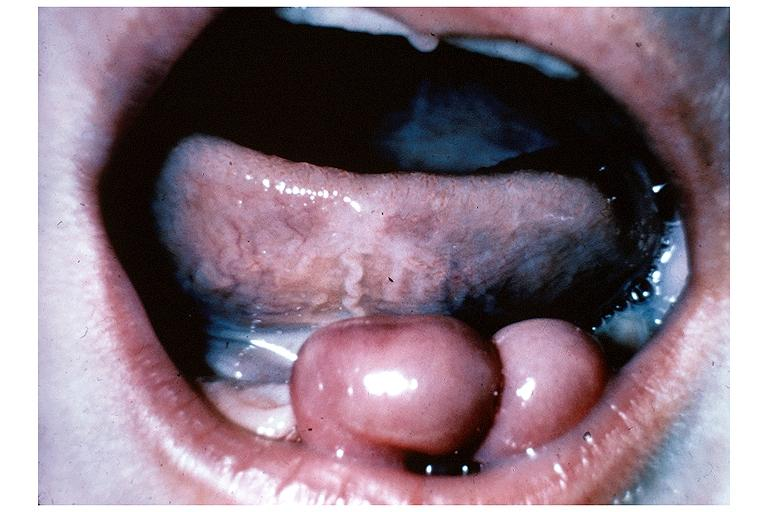what does this image show?
Answer the question using a single word or phrase. Congenital epulis 